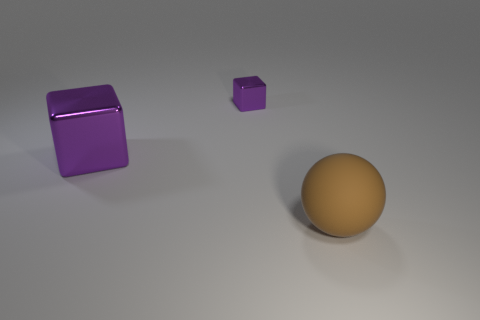Is there anything else that has the same material as the big brown sphere?
Offer a very short reply. No. How big is the thing that is in front of the purple cube in front of the small purple thing?
Your response must be concise. Large. Is the number of yellow cubes greater than the number of tiny objects?
Make the answer very short. No. Is the number of purple metallic objects that are on the left side of the tiny purple metal cube greater than the number of large things left of the large purple block?
Make the answer very short. Yes. What size is the object that is in front of the small thing and to the left of the big ball?
Offer a terse response. Large. What number of purple shiny objects have the same size as the brown rubber thing?
Provide a succinct answer. 1. There is a purple metal thing right of the large purple object; is it the same shape as the big purple metal thing?
Provide a succinct answer. Yes. Is the number of large brown objects that are behind the large brown thing less than the number of large gray cylinders?
Offer a very short reply. No. Are there any cubes of the same color as the small shiny thing?
Offer a very short reply. Yes. Is the shape of the big purple thing the same as the metallic object that is behind the big purple metal object?
Make the answer very short. Yes. 